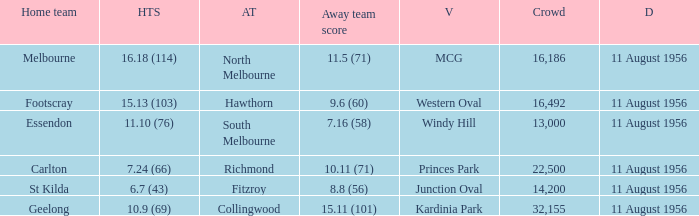What is the home team score for Footscray? 15.13 (103). 